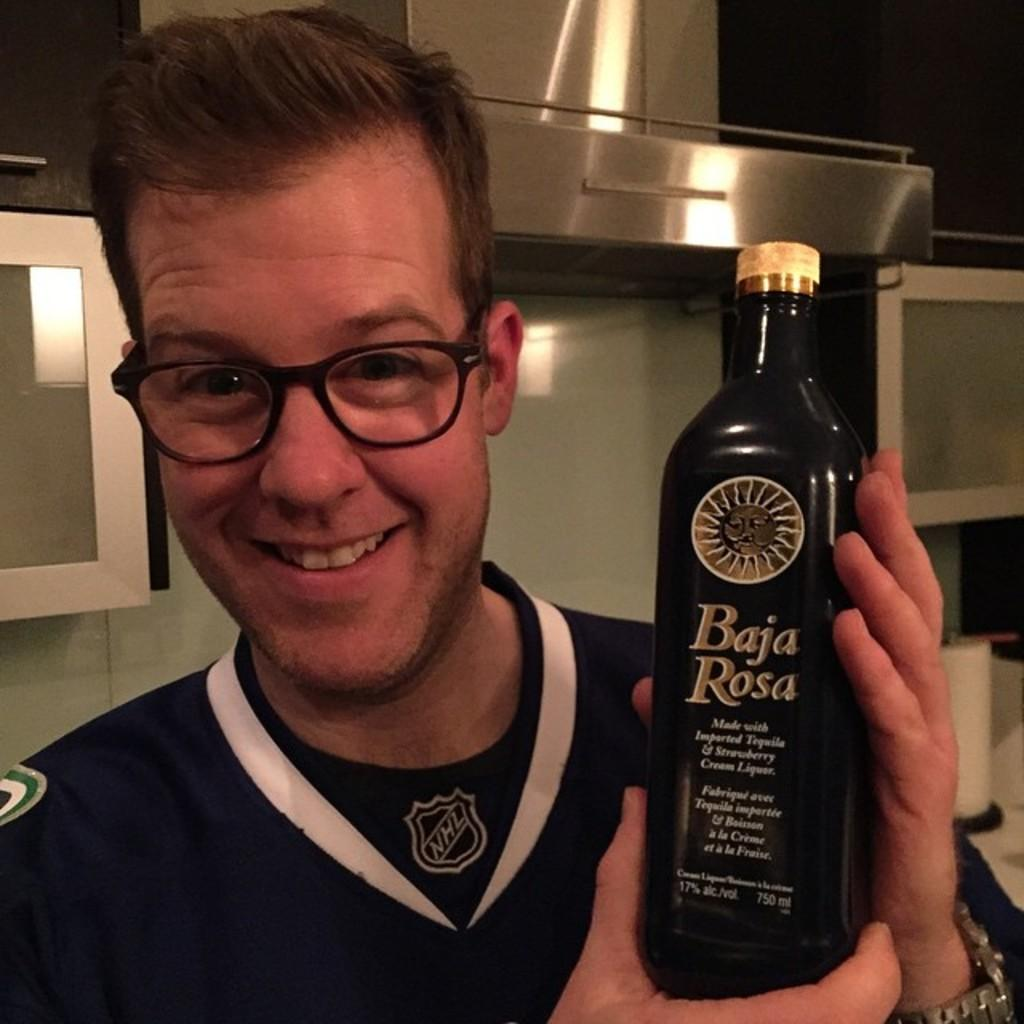<image>
Relay a brief, clear account of the picture shown. Man holding a bottle which says Baja Rosa on it. 